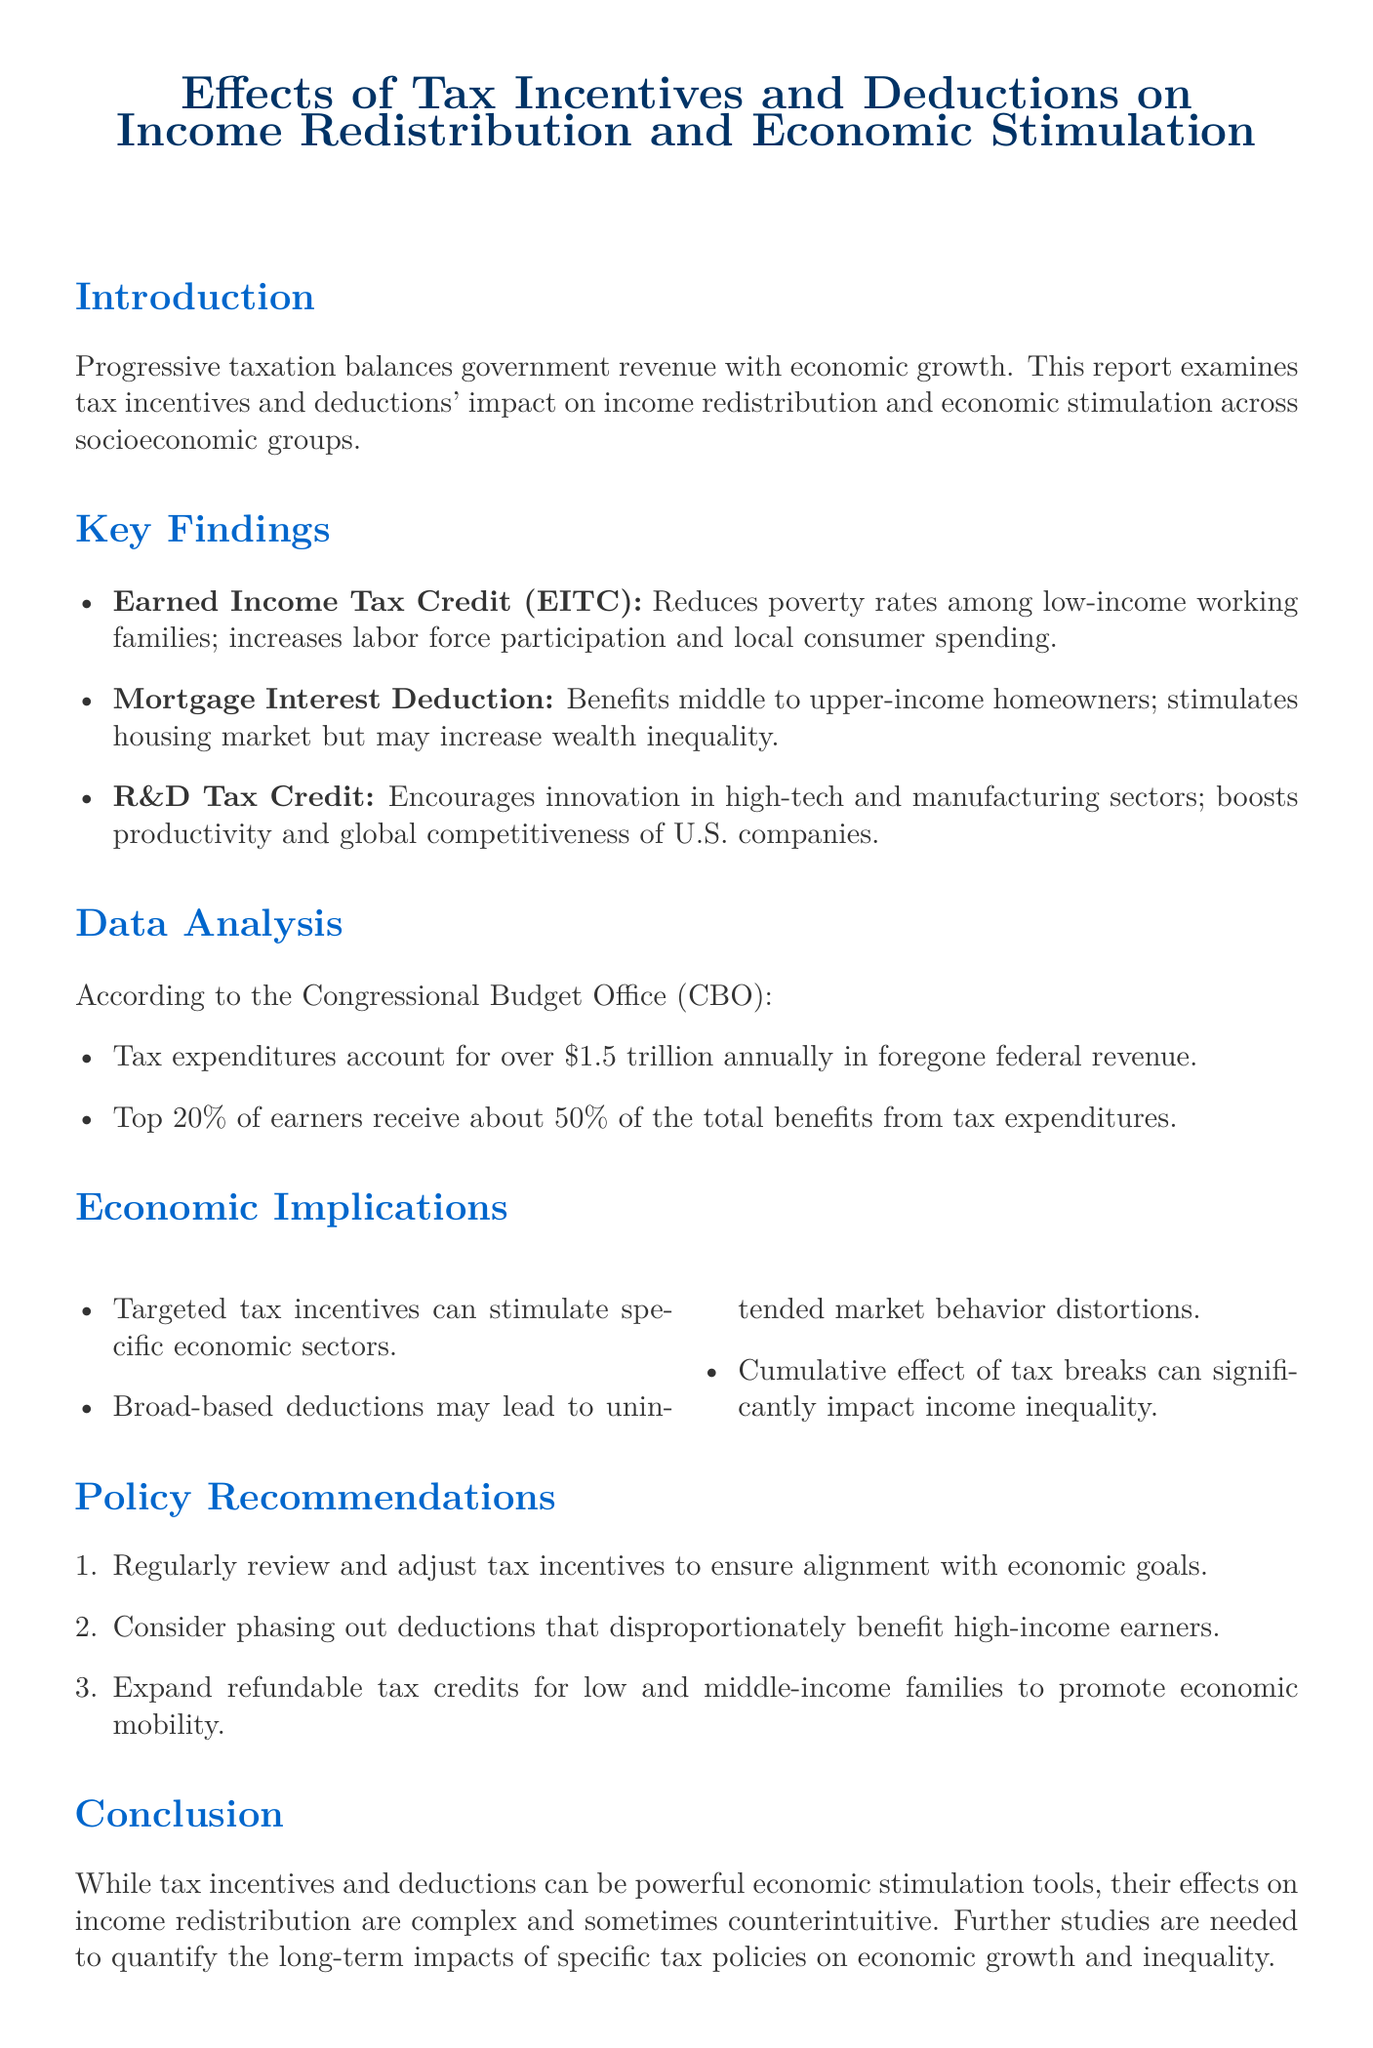What is the title of the report? The title of the report is provided at the beginning of the document and is directly mentioned.
Answer: Effects of Tax Incentives and Deductions on Income Redistribution and Economic Stimulation What is the impact of the Earned Income Tax Credit (EITC)? The impact of the EITC is outlined in the key findings section of the report.
Answer: Significantly reduces poverty rates among low-income working families How much do tax expenditures account for annually? The document includes a specific statistic regarding the annual figure of tax expenditures in the data analysis section.
Answer: Over $1.5 trillion Which socioeconomic group primarily benefits from the Mortgage Interest Deduction? The document specifies which group benefits most from this deduction within the key findings.
Answer: Middle to upper-income homeowners What is one of the economic implications of broad-based deductions? The document discusses various economic implications and specifies one related to broad-based deductions.
Answer: May lead to unintended distortions in market behavior What is one policy recommendation made in the report? The report lists several policy recommendations that can be found in the respective section.
Answer: Regularly review and adjust tax incentives to ensure alignment with economic goals 